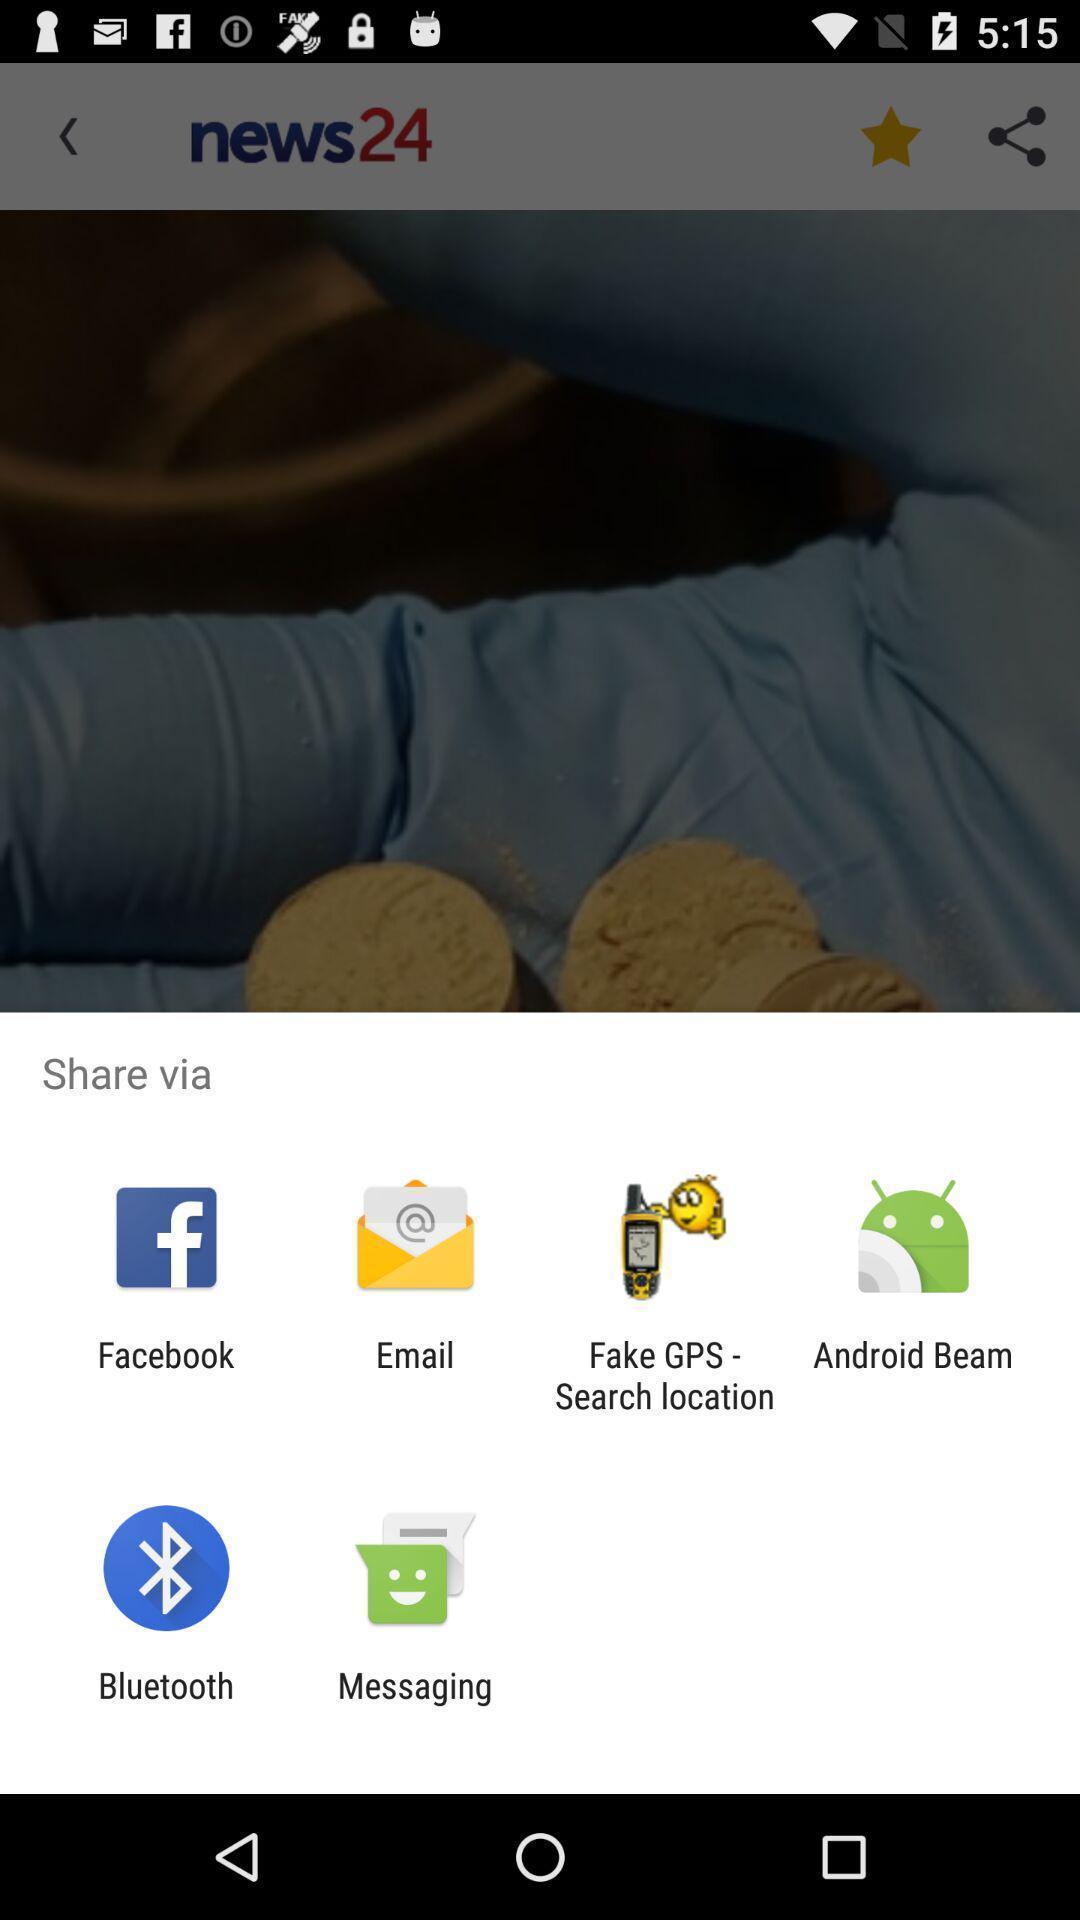Tell me about the visual elements in this screen capture. Pop-up with different options for sharing a link. 